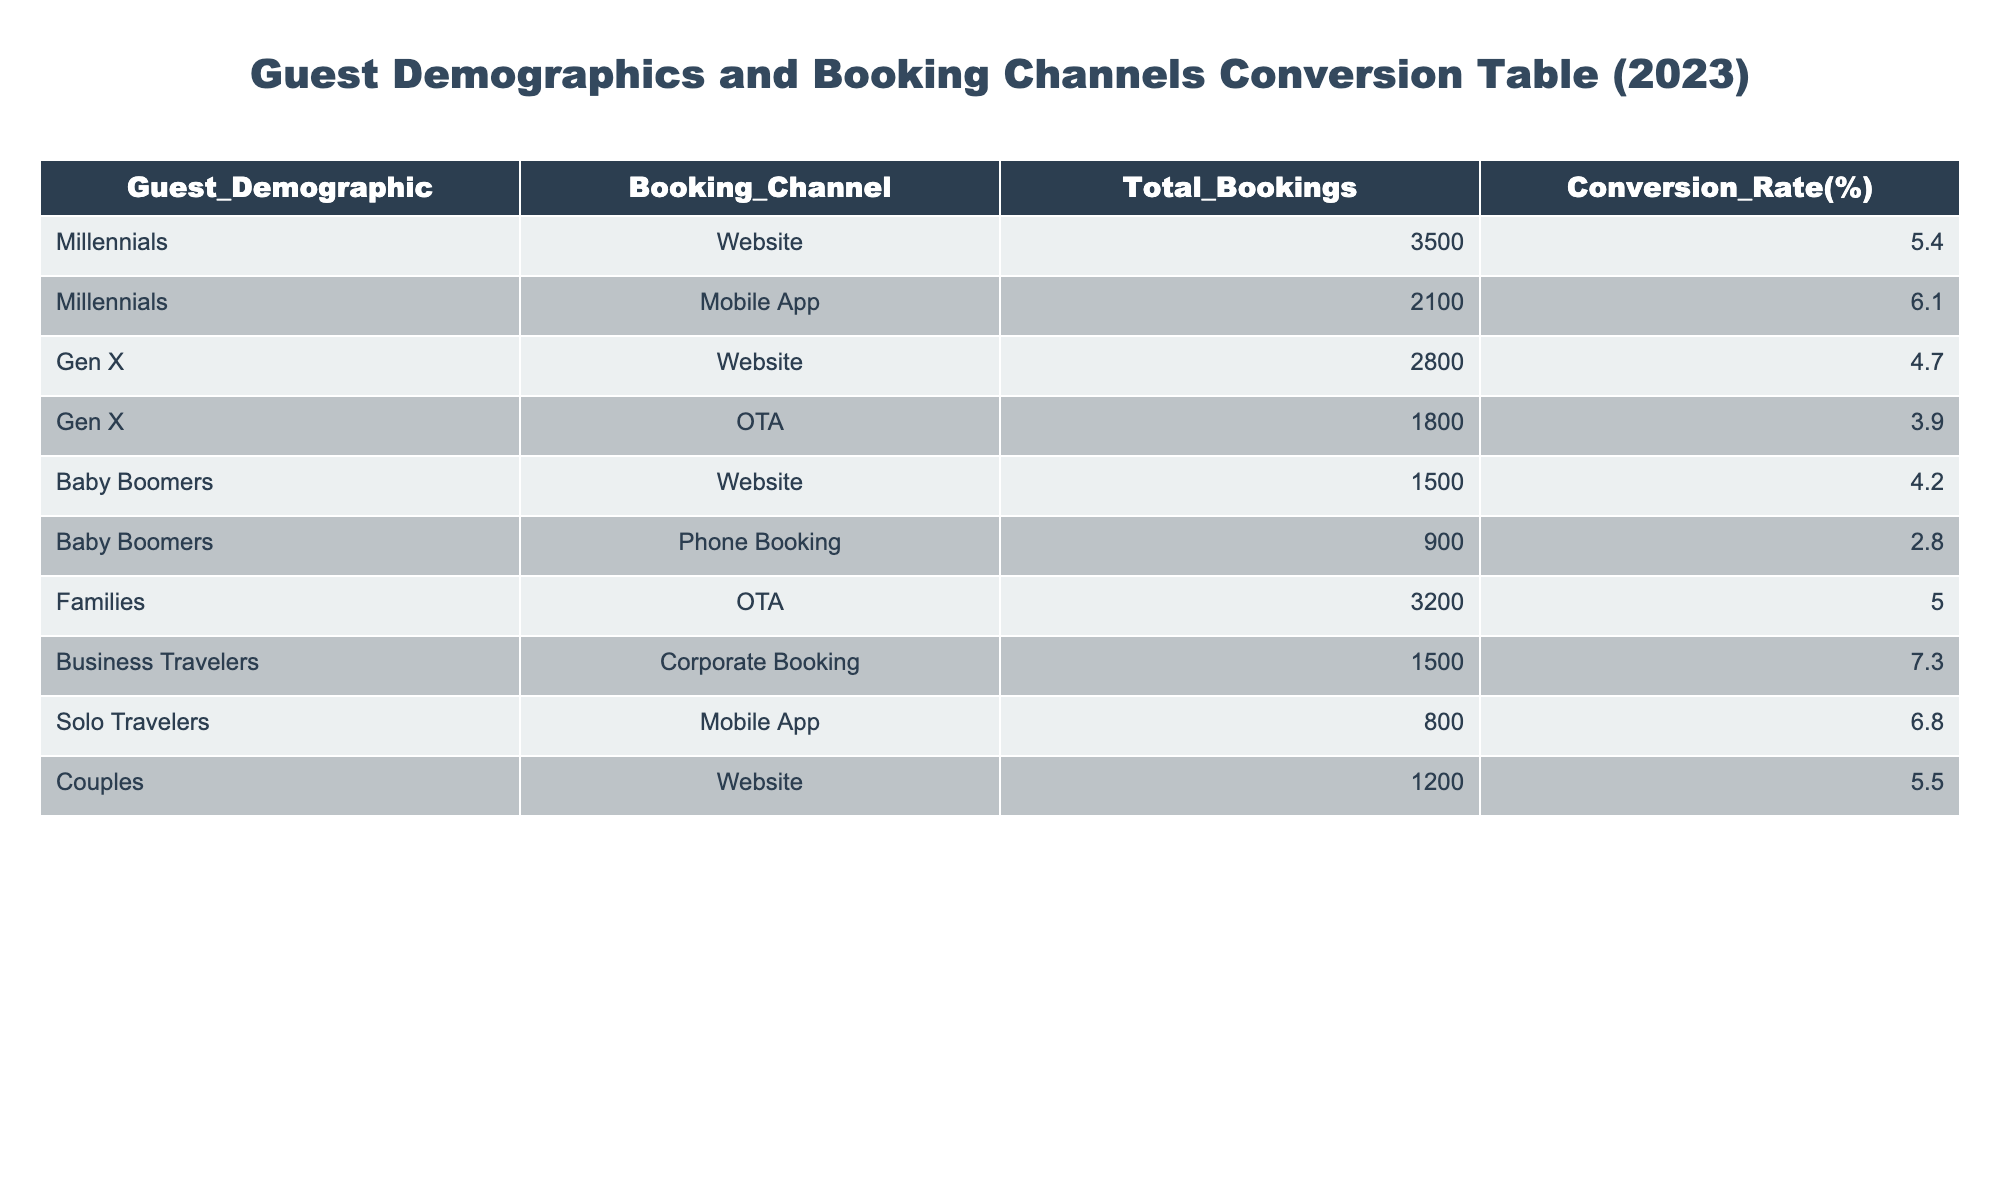What is the total number of bookings from Millennials using the Mobile App? The table shows that there were 2100 total bookings from Millennials using the Mobile App. This value is retrieved directly from the corresponding row in the table.
Answer: 2100 Which booking channel had the highest conversion rate among Baby Boomers? For Baby Boomers, the conversion rates are as follows: Website (4.2%) and Phone Booking (2.8%). The highest conversion rate from these is 4.2% for the Website. This is determined by comparing the conversion rates for each row associated with Baby Boomers.
Answer: 4.2% What is the total number of bookings for Families across all booking channels? Families have 3200 bookings through the OTA channel. Since this is the only entry related to Families in the table, the total number of bookings remains 3200.
Answer: 3200 Is the conversion rate for Solo Travelers higher than that for Couples? The conversion rate for Solo Travelers is 6.8% and for Couples, it is 5.5%. Since 6.8% is greater than 5.5%, we can confirm that Solo Travelers have a higher conversion rate than Couples. This is verified by comparing the respective conversion rates found in the table.
Answer: Yes How many more bookings do Business Travelers have compared to Baby Boomers? Business Travelers have 1500 total bookings and Baby Boomers have a total of 2400 bookings (1500 from Website and 900 from Phone Booking). To find how many more bookings Business Travelers have, we subtract the number of bookings for Baby Boomers from that of Business Travelers: 1500 - 2400 = -900. This shows Baby Boomers have 900 more bookings than Business Travelers.
Answer: 900 more for Baby Boomers What is the average conversion rate across all demographics for bookings made through the Website? The conversion rates for the Website are 5.4% (Millennials), 4.7% (Gen X), 4.2% (Baby Boomers), and 5.5% (Couples). We add these rates: 5.4 + 4.7 + 4.2 + 5.5 = 19.8%. Then, we divide this sum by 4 (the number of data points): 19.8 / 4 = 4.95%. Thus, the average conversion rate for the Website is 4.95%.
Answer: 4.95% Which guest demographic made the fewest bookings through the Phone Booking channel? Only Baby Boomers utilized the Phone Booking channel, with a total of 900 bookings. Therefore, since they are the only demographic that used this channel, it can be concluded that they made the fewest bookings through it.
Answer: Baby Boomers What is the total number of bookings for all demographics using Mobile Apps? The total bookings for Mobile Apps come from Millennials (2100) and Solo Travelers (800). We add these two figures: 2100 + 800 = 2900. Therefore, the total number of bookings using Mobile Apps across these demographics is 2900.
Answer: 2900 Do Couples have a higher conversion rate than Gen X for OTA bookings? Gen X has a conversion rate of 3.9% for OTA bookings. However, Couples do not have any entries under OTA bookings. Since the conversion rate for Couples in the table does not exist for this channel, it's not applicable to compare. Thus, we conclude that this statement cannot be validated.
Answer: No (not applicable) 